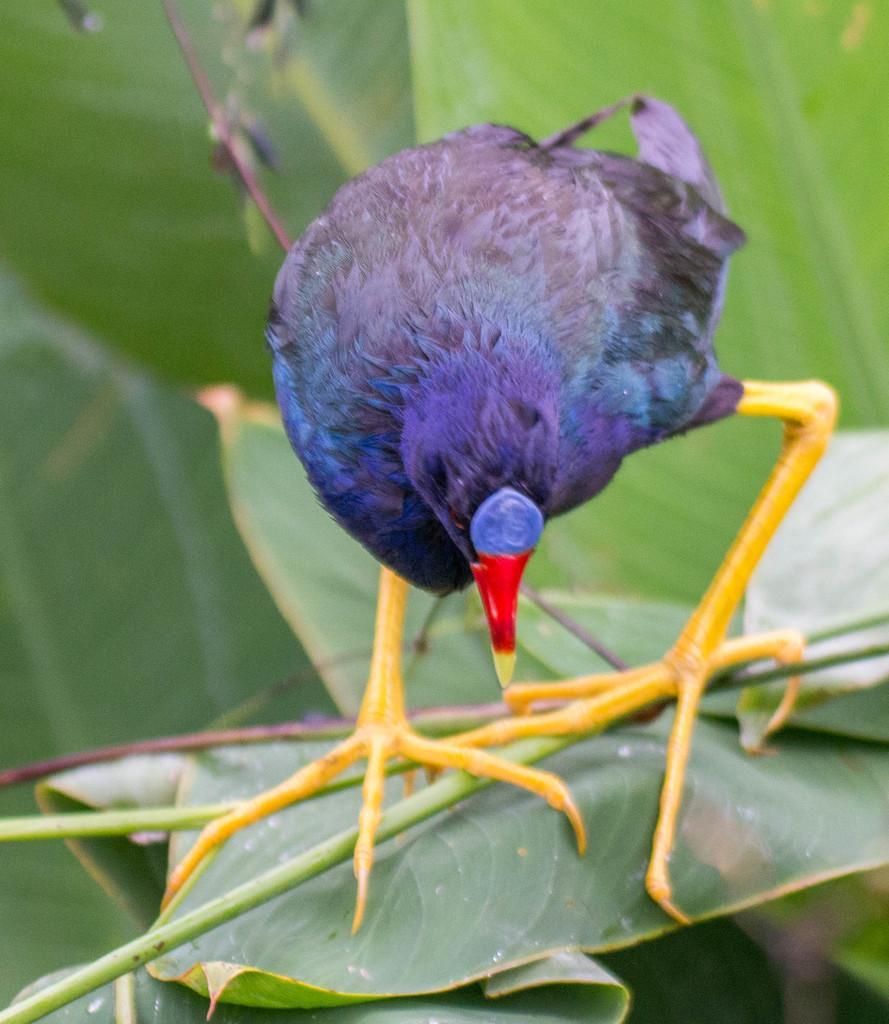In one or two sentences, can you explain what this image depicts? In this picture we can see a purple color bird with a red beak standing on the green leaves. 